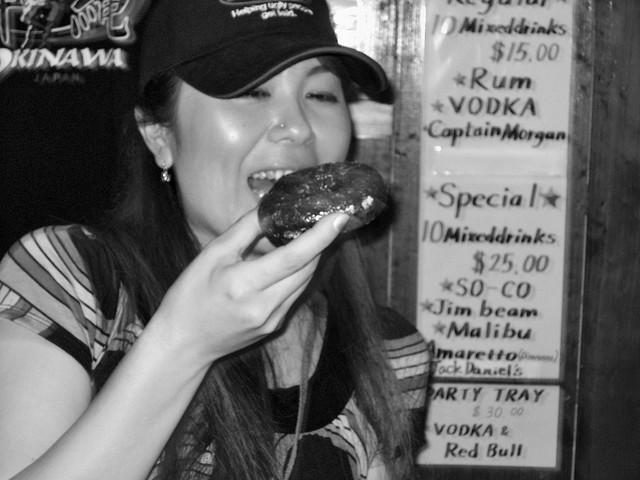Verify the accuracy of this image caption: "The person is touching the donut.".
Answer yes or no. Yes. 